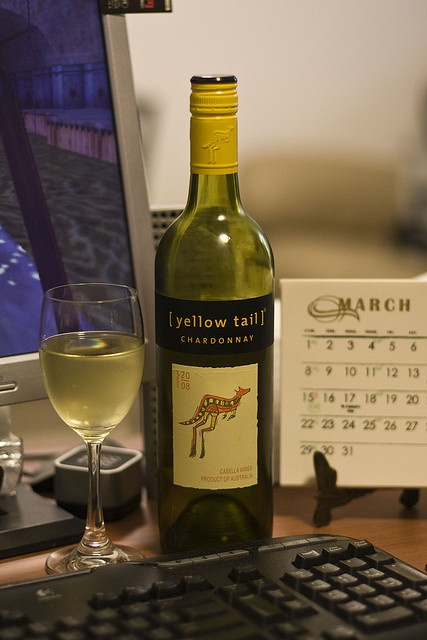Describe the objects in this image and their specific colors. I can see bottle in black, olive, and tan tones, tv in black, navy, and gray tones, keyboard in black and gray tones, and wine glass in black, olive, and tan tones in this image. 